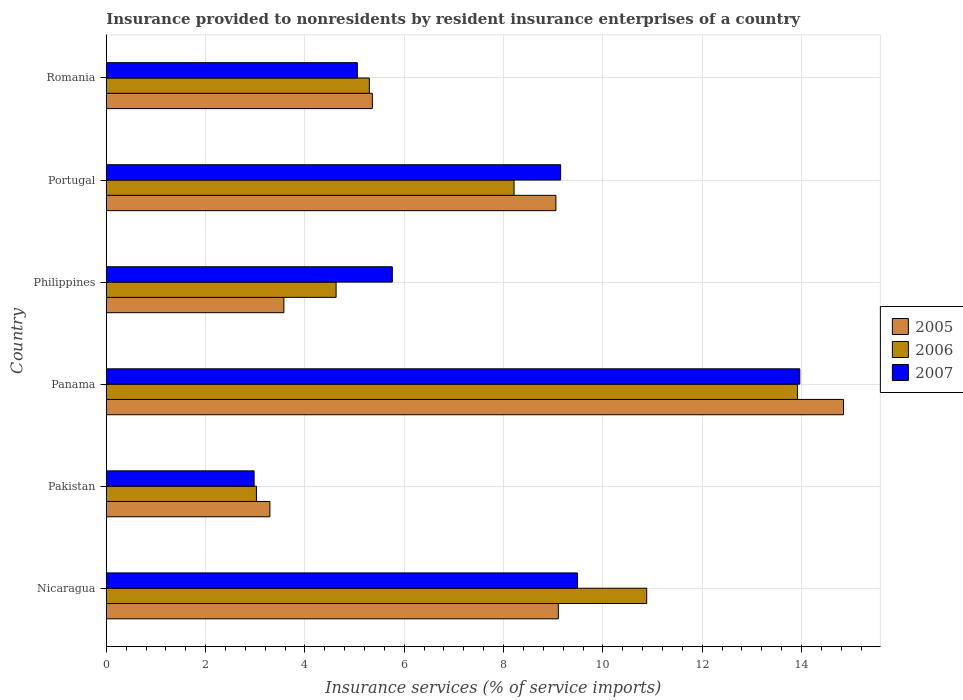How many bars are there on the 2nd tick from the top?
Your answer should be compact. 3. How many bars are there on the 2nd tick from the bottom?
Ensure brevity in your answer.  3. What is the label of the 4th group of bars from the top?
Provide a succinct answer. Panama. In how many cases, is the number of bars for a given country not equal to the number of legend labels?
Give a very brief answer. 0. What is the insurance provided to nonresidents in 2006 in Pakistan?
Offer a very short reply. 3.02. Across all countries, what is the maximum insurance provided to nonresidents in 2007?
Ensure brevity in your answer.  13.97. Across all countries, what is the minimum insurance provided to nonresidents in 2007?
Provide a succinct answer. 2.98. In which country was the insurance provided to nonresidents in 2006 maximum?
Your answer should be very brief. Panama. What is the total insurance provided to nonresidents in 2007 in the graph?
Provide a short and direct response. 46.4. What is the difference between the insurance provided to nonresidents in 2007 in Philippines and that in Romania?
Provide a short and direct response. 0.7. What is the difference between the insurance provided to nonresidents in 2006 in Philippines and the insurance provided to nonresidents in 2007 in Pakistan?
Make the answer very short. 1.65. What is the average insurance provided to nonresidents in 2006 per country?
Make the answer very short. 7.66. What is the difference between the insurance provided to nonresidents in 2006 and insurance provided to nonresidents in 2007 in Pakistan?
Your answer should be compact. 0.05. In how many countries, is the insurance provided to nonresidents in 2007 greater than 11.6 %?
Offer a very short reply. 1. What is the ratio of the insurance provided to nonresidents in 2007 in Pakistan to that in Panama?
Keep it short and to the point. 0.21. Is the insurance provided to nonresidents in 2007 in Nicaragua less than that in Philippines?
Offer a terse response. No. Is the difference between the insurance provided to nonresidents in 2006 in Pakistan and Portugal greater than the difference between the insurance provided to nonresidents in 2007 in Pakistan and Portugal?
Give a very brief answer. Yes. What is the difference between the highest and the second highest insurance provided to nonresidents in 2007?
Your response must be concise. 4.48. What is the difference between the highest and the lowest insurance provided to nonresidents in 2006?
Your answer should be compact. 10.9. In how many countries, is the insurance provided to nonresidents in 2005 greater than the average insurance provided to nonresidents in 2005 taken over all countries?
Ensure brevity in your answer.  3. Is the sum of the insurance provided to nonresidents in 2007 in Panama and Philippines greater than the maximum insurance provided to nonresidents in 2005 across all countries?
Offer a very short reply. Yes. What does the 3rd bar from the top in Romania represents?
Your answer should be very brief. 2005. Is it the case that in every country, the sum of the insurance provided to nonresidents in 2005 and insurance provided to nonresidents in 2007 is greater than the insurance provided to nonresidents in 2006?
Provide a short and direct response. Yes. Are all the bars in the graph horizontal?
Make the answer very short. Yes. How many countries are there in the graph?
Keep it short and to the point. 6. What is the difference between two consecutive major ticks on the X-axis?
Your answer should be very brief. 2. Are the values on the major ticks of X-axis written in scientific E-notation?
Provide a succinct answer. No. Does the graph contain grids?
Provide a succinct answer. Yes. Where does the legend appear in the graph?
Your answer should be very brief. Center right. How many legend labels are there?
Provide a succinct answer. 3. What is the title of the graph?
Ensure brevity in your answer.  Insurance provided to nonresidents by resident insurance enterprises of a country. Does "2011" appear as one of the legend labels in the graph?
Offer a terse response. No. What is the label or title of the X-axis?
Provide a succinct answer. Insurance services (% of service imports). What is the Insurance services (% of service imports) in 2005 in Nicaragua?
Your response must be concise. 9.1. What is the Insurance services (% of service imports) in 2006 in Nicaragua?
Your response must be concise. 10.88. What is the Insurance services (% of service imports) in 2007 in Nicaragua?
Keep it short and to the point. 9.49. What is the Insurance services (% of service imports) of 2005 in Pakistan?
Provide a short and direct response. 3.29. What is the Insurance services (% of service imports) in 2006 in Pakistan?
Offer a terse response. 3.02. What is the Insurance services (% of service imports) of 2007 in Pakistan?
Offer a very short reply. 2.98. What is the Insurance services (% of service imports) in 2005 in Panama?
Make the answer very short. 14.85. What is the Insurance services (% of service imports) in 2006 in Panama?
Provide a succinct answer. 13.92. What is the Insurance services (% of service imports) in 2007 in Panama?
Provide a short and direct response. 13.97. What is the Insurance services (% of service imports) of 2005 in Philippines?
Ensure brevity in your answer.  3.58. What is the Insurance services (% of service imports) in 2006 in Philippines?
Make the answer very short. 4.63. What is the Insurance services (% of service imports) of 2007 in Philippines?
Give a very brief answer. 5.76. What is the Insurance services (% of service imports) of 2005 in Portugal?
Your answer should be very brief. 9.05. What is the Insurance services (% of service imports) in 2006 in Portugal?
Offer a very short reply. 8.21. What is the Insurance services (% of service imports) in 2007 in Portugal?
Ensure brevity in your answer.  9.15. What is the Insurance services (% of service imports) in 2005 in Romania?
Provide a succinct answer. 5.36. What is the Insurance services (% of service imports) in 2006 in Romania?
Ensure brevity in your answer.  5.3. What is the Insurance services (% of service imports) in 2007 in Romania?
Your response must be concise. 5.05. Across all countries, what is the maximum Insurance services (% of service imports) of 2005?
Provide a short and direct response. 14.85. Across all countries, what is the maximum Insurance services (% of service imports) of 2006?
Offer a very short reply. 13.92. Across all countries, what is the maximum Insurance services (% of service imports) of 2007?
Keep it short and to the point. 13.97. Across all countries, what is the minimum Insurance services (% of service imports) of 2005?
Provide a short and direct response. 3.29. Across all countries, what is the minimum Insurance services (% of service imports) of 2006?
Provide a short and direct response. 3.02. Across all countries, what is the minimum Insurance services (% of service imports) of 2007?
Offer a very short reply. 2.98. What is the total Insurance services (% of service imports) in 2005 in the graph?
Your answer should be very brief. 45.23. What is the total Insurance services (% of service imports) in 2006 in the graph?
Keep it short and to the point. 45.96. What is the total Insurance services (% of service imports) of 2007 in the graph?
Keep it short and to the point. 46.4. What is the difference between the Insurance services (% of service imports) of 2005 in Nicaragua and that in Pakistan?
Make the answer very short. 5.81. What is the difference between the Insurance services (% of service imports) in 2006 in Nicaragua and that in Pakistan?
Make the answer very short. 7.86. What is the difference between the Insurance services (% of service imports) in 2007 in Nicaragua and that in Pakistan?
Give a very brief answer. 6.51. What is the difference between the Insurance services (% of service imports) in 2005 in Nicaragua and that in Panama?
Your answer should be very brief. -5.74. What is the difference between the Insurance services (% of service imports) of 2006 in Nicaragua and that in Panama?
Make the answer very short. -3.04. What is the difference between the Insurance services (% of service imports) in 2007 in Nicaragua and that in Panama?
Give a very brief answer. -4.48. What is the difference between the Insurance services (% of service imports) of 2005 in Nicaragua and that in Philippines?
Your answer should be very brief. 5.53. What is the difference between the Insurance services (% of service imports) of 2006 in Nicaragua and that in Philippines?
Ensure brevity in your answer.  6.26. What is the difference between the Insurance services (% of service imports) of 2007 in Nicaragua and that in Philippines?
Your answer should be very brief. 3.73. What is the difference between the Insurance services (% of service imports) in 2005 in Nicaragua and that in Portugal?
Your response must be concise. 0.05. What is the difference between the Insurance services (% of service imports) of 2006 in Nicaragua and that in Portugal?
Give a very brief answer. 2.67. What is the difference between the Insurance services (% of service imports) of 2007 in Nicaragua and that in Portugal?
Give a very brief answer. 0.34. What is the difference between the Insurance services (% of service imports) of 2005 in Nicaragua and that in Romania?
Your answer should be compact. 3.75. What is the difference between the Insurance services (% of service imports) in 2006 in Nicaragua and that in Romania?
Offer a very short reply. 5.59. What is the difference between the Insurance services (% of service imports) of 2007 in Nicaragua and that in Romania?
Give a very brief answer. 4.43. What is the difference between the Insurance services (% of service imports) of 2005 in Pakistan and that in Panama?
Your answer should be very brief. -11.55. What is the difference between the Insurance services (% of service imports) in 2006 in Pakistan and that in Panama?
Keep it short and to the point. -10.9. What is the difference between the Insurance services (% of service imports) of 2007 in Pakistan and that in Panama?
Your answer should be very brief. -10.99. What is the difference between the Insurance services (% of service imports) of 2005 in Pakistan and that in Philippines?
Provide a succinct answer. -0.28. What is the difference between the Insurance services (% of service imports) of 2006 in Pakistan and that in Philippines?
Your response must be concise. -1.6. What is the difference between the Insurance services (% of service imports) of 2007 in Pakistan and that in Philippines?
Your response must be concise. -2.78. What is the difference between the Insurance services (% of service imports) in 2005 in Pakistan and that in Portugal?
Offer a very short reply. -5.76. What is the difference between the Insurance services (% of service imports) of 2006 in Pakistan and that in Portugal?
Provide a succinct answer. -5.19. What is the difference between the Insurance services (% of service imports) in 2007 in Pakistan and that in Portugal?
Offer a very short reply. -6.17. What is the difference between the Insurance services (% of service imports) in 2005 in Pakistan and that in Romania?
Offer a terse response. -2.06. What is the difference between the Insurance services (% of service imports) of 2006 in Pakistan and that in Romania?
Make the answer very short. -2.27. What is the difference between the Insurance services (% of service imports) in 2007 in Pakistan and that in Romania?
Provide a short and direct response. -2.08. What is the difference between the Insurance services (% of service imports) of 2005 in Panama and that in Philippines?
Make the answer very short. 11.27. What is the difference between the Insurance services (% of service imports) of 2006 in Panama and that in Philippines?
Your answer should be very brief. 9.29. What is the difference between the Insurance services (% of service imports) of 2007 in Panama and that in Philippines?
Your response must be concise. 8.21. What is the difference between the Insurance services (% of service imports) in 2005 in Panama and that in Portugal?
Provide a succinct answer. 5.79. What is the difference between the Insurance services (% of service imports) of 2006 in Panama and that in Portugal?
Your answer should be very brief. 5.71. What is the difference between the Insurance services (% of service imports) of 2007 in Panama and that in Portugal?
Keep it short and to the point. 4.82. What is the difference between the Insurance services (% of service imports) in 2005 in Panama and that in Romania?
Your answer should be compact. 9.49. What is the difference between the Insurance services (% of service imports) in 2006 in Panama and that in Romania?
Your answer should be very brief. 8.62. What is the difference between the Insurance services (% of service imports) of 2007 in Panama and that in Romania?
Offer a terse response. 8.91. What is the difference between the Insurance services (% of service imports) in 2005 in Philippines and that in Portugal?
Give a very brief answer. -5.48. What is the difference between the Insurance services (% of service imports) in 2006 in Philippines and that in Portugal?
Offer a very short reply. -3.58. What is the difference between the Insurance services (% of service imports) of 2007 in Philippines and that in Portugal?
Ensure brevity in your answer.  -3.39. What is the difference between the Insurance services (% of service imports) in 2005 in Philippines and that in Romania?
Offer a very short reply. -1.78. What is the difference between the Insurance services (% of service imports) of 2006 in Philippines and that in Romania?
Offer a terse response. -0.67. What is the difference between the Insurance services (% of service imports) of 2007 in Philippines and that in Romania?
Provide a short and direct response. 0.7. What is the difference between the Insurance services (% of service imports) of 2005 in Portugal and that in Romania?
Your answer should be compact. 3.7. What is the difference between the Insurance services (% of service imports) in 2006 in Portugal and that in Romania?
Your answer should be very brief. 2.91. What is the difference between the Insurance services (% of service imports) in 2007 in Portugal and that in Romania?
Make the answer very short. 4.09. What is the difference between the Insurance services (% of service imports) in 2005 in Nicaragua and the Insurance services (% of service imports) in 2006 in Pakistan?
Your response must be concise. 6.08. What is the difference between the Insurance services (% of service imports) of 2005 in Nicaragua and the Insurance services (% of service imports) of 2007 in Pakistan?
Offer a very short reply. 6.13. What is the difference between the Insurance services (% of service imports) of 2006 in Nicaragua and the Insurance services (% of service imports) of 2007 in Pakistan?
Your answer should be very brief. 7.91. What is the difference between the Insurance services (% of service imports) of 2005 in Nicaragua and the Insurance services (% of service imports) of 2006 in Panama?
Your answer should be very brief. -4.82. What is the difference between the Insurance services (% of service imports) in 2005 in Nicaragua and the Insurance services (% of service imports) in 2007 in Panama?
Provide a succinct answer. -4.86. What is the difference between the Insurance services (% of service imports) of 2006 in Nicaragua and the Insurance services (% of service imports) of 2007 in Panama?
Your answer should be very brief. -3.08. What is the difference between the Insurance services (% of service imports) of 2005 in Nicaragua and the Insurance services (% of service imports) of 2006 in Philippines?
Make the answer very short. 4.48. What is the difference between the Insurance services (% of service imports) in 2005 in Nicaragua and the Insurance services (% of service imports) in 2007 in Philippines?
Keep it short and to the point. 3.34. What is the difference between the Insurance services (% of service imports) in 2006 in Nicaragua and the Insurance services (% of service imports) in 2007 in Philippines?
Your response must be concise. 5.12. What is the difference between the Insurance services (% of service imports) of 2005 in Nicaragua and the Insurance services (% of service imports) of 2006 in Portugal?
Provide a succinct answer. 0.89. What is the difference between the Insurance services (% of service imports) of 2005 in Nicaragua and the Insurance services (% of service imports) of 2007 in Portugal?
Your response must be concise. -0.05. What is the difference between the Insurance services (% of service imports) in 2006 in Nicaragua and the Insurance services (% of service imports) in 2007 in Portugal?
Provide a short and direct response. 1.73. What is the difference between the Insurance services (% of service imports) of 2005 in Nicaragua and the Insurance services (% of service imports) of 2006 in Romania?
Your answer should be compact. 3.81. What is the difference between the Insurance services (% of service imports) in 2005 in Nicaragua and the Insurance services (% of service imports) in 2007 in Romania?
Offer a very short reply. 4.05. What is the difference between the Insurance services (% of service imports) of 2006 in Nicaragua and the Insurance services (% of service imports) of 2007 in Romania?
Your answer should be very brief. 5.83. What is the difference between the Insurance services (% of service imports) of 2005 in Pakistan and the Insurance services (% of service imports) of 2006 in Panama?
Your answer should be very brief. -10.62. What is the difference between the Insurance services (% of service imports) of 2005 in Pakistan and the Insurance services (% of service imports) of 2007 in Panama?
Your response must be concise. -10.67. What is the difference between the Insurance services (% of service imports) in 2006 in Pakistan and the Insurance services (% of service imports) in 2007 in Panama?
Provide a short and direct response. -10.94. What is the difference between the Insurance services (% of service imports) in 2005 in Pakistan and the Insurance services (% of service imports) in 2006 in Philippines?
Your answer should be very brief. -1.33. What is the difference between the Insurance services (% of service imports) in 2005 in Pakistan and the Insurance services (% of service imports) in 2007 in Philippines?
Offer a terse response. -2.47. What is the difference between the Insurance services (% of service imports) in 2006 in Pakistan and the Insurance services (% of service imports) in 2007 in Philippines?
Your response must be concise. -2.74. What is the difference between the Insurance services (% of service imports) of 2005 in Pakistan and the Insurance services (% of service imports) of 2006 in Portugal?
Keep it short and to the point. -4.92. What is the difference between the Insurance services (% of service imports) of 2005 in Pakistan and the Insurance services (% of service imports) of 2007 in Portugal?
Give a very brief answer. -5.86. What is the difference between the Insurance services (% of service imports) of 2006 in Pakistan and the Insurance services (% of service imports) of 2007 in Portugal?
Give a very brief answer. -6.13. What is the difference between the Insurance services (% of service imports) of 2005 in Pakistan and the Insurance services (% of service imports) of 2006 in Romania?
Offer a terse response. -2. What is the difference between the Insurance services (% of service imports) of 2005 in Pakistan and the Insurance services (% of service imports) of 2007 in Romania?
Offer a terse response. -1.76. What is the difference between the Insurance services (% of service imports) in 2006 in Pakistan and the Insurance services (% of service imports) in 2007 in Romania?
Ensure brevity in your answer.  -2.03. What is the difference between the Insurance services (% of service imports) in 2005 in Panama and the Insurance services (% of service imports) in 2006 in Philippines?
Offer a terse response. 10.22. What is the difference between the Insurance services (% of service imports) of 2005 in Panama and the Insurance services (% of service imports) of 2007 in Philippines?
Give a very brief answer. 9.09. What is the difference between the Insurance services (% of service imports) of 2006 in Panama and the Insurance services (% of service imports) of 2007 in Philippines?
Your answer should be very brief. 8.16. What is the difference between the Insurance services (% of service imports) of 2005 in Panama and the Insurance services (% of service imports) of 2006 in Portugal?
Ensure brevity in your answer.  6.63. What is the difference between the Insurance services (% of service imports) of 2005 in Panama and the Insurance services (% of service imports) of 2007 in Portugal?
Your answer should be compact. 5.7. What is the difference between the Insurance services (% of service imports) of 2006 in Panama and the Insurance services (% of service imports) of 2007 in Portugal?
Provide a succinct answer. 4.77. What is the difference between the Insurance services (% of service imports) in 2005 in Panama and the Insurance services (% of service imports) in 2006 in Romania?
Give a very brief answer. 9.55. What is the difference between the Insurance services (% of service imports) of 2005 in Panama and the Insurance services (% of service imports) of 2007 in Romania?
Ensure brevity in your answer.  9.79. What is the difference between the Insurance services (% of service imports) in 2006 in Panama and the Insurance services (% of service imports) in 2007 in Romania?
Keep it short and to the point. 8.86. What is the difference between the Insurance services (% of service imports) of 2005 in Philippines and the Insurance services (% of service imports) of 2006 in Portugal?
Make the answer very short. -4.64. What is the difference between the Insurance services (% of service imports) in 2005 in Philippines and the Insurance services (% of service imports) in 2007 in Portugal?
Your answer should be compact. -5.57. What is the difference between the Insurance services (% of service imports) in 2006 in Philippines and the Insurance services (% of service imports) in 2007 in Portugal?
Provide a succinct answer. -4.52. What is the difference between the Insurance services (% of service imports) of 2005 in Philippines and the Insurance services (% of service imports) of 2006 in Romania?
Give a very brief answer. -1.72. What is the difference between the Insurance services (% of service imports) in 2005 in Philippines and the Insurance services (% of service imports) in 2007 in Romania?
Your response must be concise. -1.48. What is the difference between the Insurance services (% of service imports) in 2006 in Philippines and the Insurance services (% of service imports) in 2007 in Romania?
Make the answer very short. -0.43. What is the difference between the Insurance services (% of service imports) of 2005 in Portugal and the Insurance services (% of service imports) of 2006 in Romania?
Provide a succinct answer. 3.76. What is the difference between the Insurance services (% of service imports) in 2005 in Portugal and the Insurance services (% of service imports) in 2007 in Romania?
Your answer should be very brief. 4. What is the difference between the Insurance services (% of service imports) of 2006 in Portugal and the Insurance services (% of service imports) of 2007 in Romania?
Your response must be concise. 3.16. What is the average Insurance services (% of service imports) of 2005 per country?
Your response must be concise. 7.54. What is the average Insurance services (% of service imports) in 2006 per country?
Your answer should be very brief. 7.66. What is the average Insurance services (% of service imports) in 2007 per country?
Ensure brevity in your answer.  7.73. What is the difference between the Insurance services (% of service imports) in 2005 and Insurance services (% of service imports) in 2006 in Nicaragua?
Make the answer very short. -1.78. What is the difference between the Insurance services (% of service imports) of 2005 and Insurance services (% of service imports) of 2007 in Nicaragua?
Give a very brief answer. -0.39. What is the difference between the Insurance services (% of service imports) of 2006 and Insurance services (% of service imports) of 2007 in Nicaragua?
Provide a short and direct response. 1.39. What is the difference between the Insurance services (% of service imports) in 2005 and Insurance services (% of service imports) in 2006 in Pakistan?
Provide a succinct answer. 0.27. What is the difference between the Insurance services (% of service imports) in 2005 and Insurance services (% of service imports) in 2007 in Pakistan?
Ensure brevity in your answer.  0.32. What is the difference between the Insurance services (% of service imports) in 2006 and Insurance services (% of service imports) in 2007 in Pakistan?
Your answer should be compact. 0.05. What is the difference between the Insurance services (% of service imports) of 2005 and Insurance services (% of service imports) of 2006 in Panama?
Your response must be concise. 0.93. What is the difference between the Insurance services (% of service imports) in 2005 and Insurance services (% of service imports) in 2007 in Panama?
Make the answer very short. 0.88. What is the difference between the Insurance services (% of service imports) of 2006 and Insurance services (% of service imports) of 2007 in Panama?
Provide a succinct answer. -0.05. What is the difference between the Insurance services (% of service imports) in 2005 and Insurance services (% of service imports) in 2006 in Philippines?
Your answer should be compact. -1.05. What is the difference between the Insurance services (% of service imports) in 2005 and Insurance services (% of service imports) in 2007 in Philippines?
Your response must be concise. -2.18. What is the difference between the Insurance services (% of service imports) of 2006 and Insurance services (% of service imports) of 2007 in Philippines?
Make the answer very short. -1.13. What is the difference between the Insurance services (% of service imports) of 2005 and Insurance services (% of service imports) of 2006 in Portugal?
Your answer should be very brief. 0.84. What is the difference between the Insurance services (% of service imports) of 2005 and Insurance services (% of service imports) of 2007 in Portugal?
Give a very brief answer. -0.1. What is the difference between the Insurance services (% of service imports) in 2006 and Insurance services (% of service imports) in 2007 in Portugal?
Make the answer very short. -0.94. What is the difference between the Insurance services (% of service imports) of 2005 and Insurance services (% of service imports) of 2006 in Romania?
Keep it short and to the point. 0.06. What is the difference between the Insurance services (% of service imports) of 2005 and Insurance services (% of service imports) of 2007 in Romania?
Give a very brief answer. 0.3. What is the difference between the Insurance services (% of service imports) in 2006 and Insurance services (% of service imports) in 2007 in Romania?
Keep it short and to the point. 0.24. What is the ratio of the Insurance services (% of service imports) of 2005 in Nicaragua to that in Pakistan?
Provide a short and direct response. 2.76. What is the ratio of the Insurance services (% of service imports) of 2007 in Nicaragua to that in Pakistan?
Make the answer very short. 3.19. What is the ratio of the Insurance services (% of service imports) of 2005 in Nicaragua to that in Panama?
Offer a very short reply. 0.61. What is the ratio of the Insurance services (% of service imports) in 2006 in Nicaragua to that in Panama?
Your answer should be very brief. 0.78. What is the ratio of the Insurance services (% of service imports) of 2007 in Nicaragua to that in Panama?
Provide a succinct answer. 0.68. What is the ratio of the Insurance services (% of service imports) of 2005 in Nicaragua to that in Philippines?
Offer a terse response. 2.55. What is the ratio of the Insurance services (% of service imports) in 2006 in Nicaragua to that in Philippines?
Provide a short and direct response. 2.35. What is the ratio of the Insurance services (% of service imports) in 2007 in Nicaragua to that in Philippines?
Ensure brevity in your answer.  1.65. What is the ratio of the Insurance services (% of service imports) of 2005 in Nicaragua to that in Portugal?
Ensure brevity in your answer.  1.01. What is the ratio of the Insurance services (% of service imports) of 2006 in Nicaragua to that in Portugal?
Provide a succinct answer. 1.33. What is the ratio of the Insurance services (% of service imports) of 2007 in Nicaragua to that in Portugal?
Provide a short and direct response. 1.04. What is the ratio of the Insurance services (% of service imports) of 2005 in Nicaragua to that in Romania?
Provide a succinct answer. 1.7. What is the ratio of the Insurance services (% of service imports) in 2006 in Nicaragua to that in Romania?
Your answer should be compact. 2.05. What is the ratio of the Insurance services (% of service imports) of 2007 in Nicaragua to that in Romania?
Offer a terse response. 1.88. What is the ratio of the Insurance services (% of service imports) in 2005 in Pakistan to that in Panama?
Provide a succinct answer. 0.22. What is the ratio of the Insurance services (% of service imports) in 2006 in Pakistan to that in Panama?
Provide a short and direct response. 0.22. What is the ratio of the Insurance services (% of service imports) in 2007 in Pakistan to that in Panama?
Your answer should be very brief. 0.21. What is the ratio of the Insurance services (% of service imports) of 2005 in Pakistan to that in Philippines?
Keep it short and to the point. 0.92. What is the ratio of the Insurance services (% of service imports) of 2006 in Pakistan to that in Philippines?
Your answer should be compact. 0.65. What is the ratio of the Insurance services (% of service imports) in 2007 in Pakistan to that in Philippines?
Your answer should be compact. 0.52. What is the ratio of the Insurance services (% of service imports) of 2005 in Pakistan to that in Portugal?
Keep it short and to the point. 0.36. What is the ratio of the Insurance services (% of service imports) of 2006 in Pakistan to that in Portugal?
Provide a succinct answer. 0.37. What is the ratio of the Insurance services (% of service imports) in 2007 in Pakistan to that in Portugal?
Offer a very short reply. 0.33. What is the ratio of the Insurance services (% of service imports) in 2005 in Pakistan to that in Romania?
Give a very brief answer. 0.61. What is the ratio of the Insurance services (% of service imports) of 2006 in Pakistan to that in Romania?
Your response must be concise. 0.57. What is the ratio of the Insurance services (% of service imports) in 2007 in Pakistan to that in Romania?
Offer a terse response. 0.59. What is the ratio of the Insurance services (% of service imports) in 2005 in Panama to that in Philippines?
Keep it short and to the point. 4.15. What is the ratio of the Insurance services (% of service imports) in 2006 in Panama to that in Philippines?
Offer a very short reply. 3.01. What is the ratio of the Insurance services (% of service imports) of 2007 in Panama to that in Philippines?
Your answer should be compact. 2.42. What is the ratio of the Insurance services (% of service imports) in 2005 in Panama to that in Portugal?
Give a very brief answer. 1.64. What is the ratio of the Insurance services (% of service imports) of 2006 in Panama to that in Portugal?
Give a very brief answer. 1.7. What is the ratio of the Insurance services (% of service imports) in 2007 in Panama to that in Portugal?
Keep it short and to the point. 1.53. What is the ratio of the Insurance services (% of service imports) of 2005 in Panama to that in Romania?
Your answer should be compact. 2.77. What is the ratio of the Insurance services (% of service imports) in 2006 in Panama to that in Romania?
Offer a terse response. 2.63. What is the ratio of the Insurance services (% of service imports) in 2007 in Panama to that in Romania?
Your answer should be compact. 2.76. What is the ratio of the Insurance services (% of service imports) of 2005 in Philippines to that in Portugal?
Give a very brief answer. 0.39. What is the ratio of the Insurance services (% of service imports) of 2006 in Philippines to that in Portugal?
Your answer should be compact. 0.56. What is the ratio of the Insurance services (% of service imports) in 2007 in Philippines to that in Portugal?
Offer a terse response. 0.63. What is the ratio of the Insurance services (% of service imports) of 2005 in Philippines to that in Romania?
Offer a terse response. 0.67. What is the ratio of the Insurance services (% of service imports) in 2006 in Philippines to that in Romania?
Ensure brevity in your answer.  0.87. What is the ratio of the Insurance services (% of service imports) in 2007 in Philippines to that in Romania?
Your answer should be very brief. 1.14. What is the ratio of the Insurance services (% of service imports) in 2005 in Portugal to that in Romania?
Keep it short and to the point. 1.69. What is the ratio of the Insurance services (% of service imports) of 2006 in Portugal to that in Romania?
Keep it short and to the point. 1.55. What is the ratio of the Insurance services (% of service imports) of 2007 in Portugal to that in Romania?
Provide a succinct answer. 1.81. What is the difference between the highest and the second highest Insurance services (% of service imports) in 2005?
Your answer should be very brief. 5.74. What is the difference between the highest and the second highest Insurance services (% of service imports) of 2006?
Your answer should be compact. 3.04. What is the difference between the highest and the second highest Insurance services (% of service imports) in 2007?
Provide a short and direct response. 4.48. What is the difference between the highest and the lowest Insurance services (% of service imports) of 2005?
Your answer should be compact. 11.55. What is the difference between the highest and the lowest Insurance services (% of service imports) of 2006?
Offer a terse response. 10.9. What is the difference between the highest and the lowest Insurance services (% of service imports) in 2007?
Give a very brief answer. 10.99. 